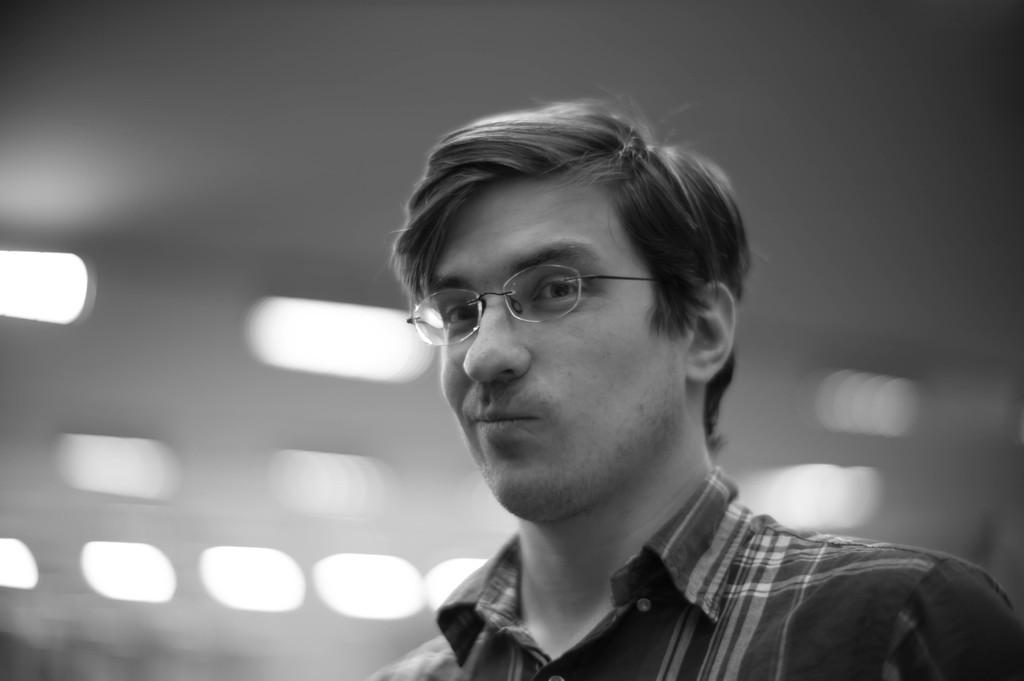What is the main subject of the image? There is a man in the image. What can be observed about the man's appearance? The man is wearing spectacles. Can you describe the background of the image? The background of the image is blurred. Is the man holding an umbrella in the image? There is no mention of an umbrella in the image, so it cannot be determined if the man is holding one. 